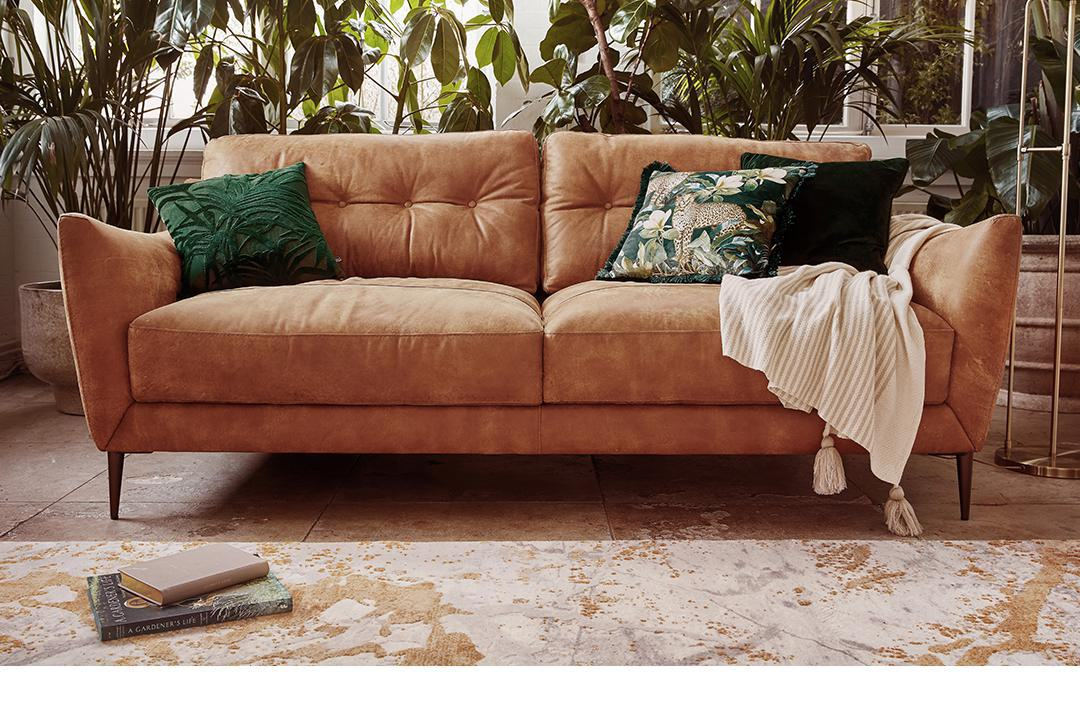What style does the room's decor suggest? The room features a chic, modern aesthetic with a touch of bohemian charm, evident in the earthy tones of the sofa, the patterned accent pillows, the lush indoor plants, and the distressed look of the cream-colored rug. 